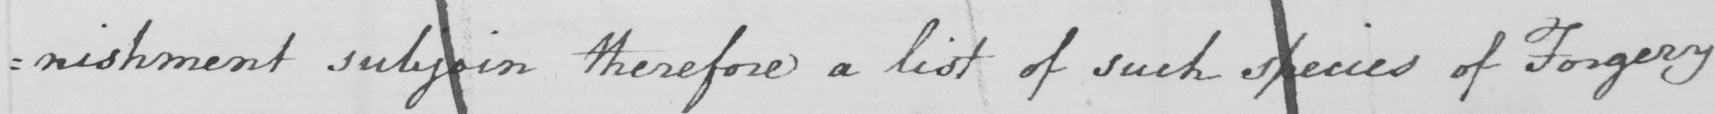Transcribe the text shown in this historical manuscript line. : nishment subjoin therefore a list of such species of Forgery 